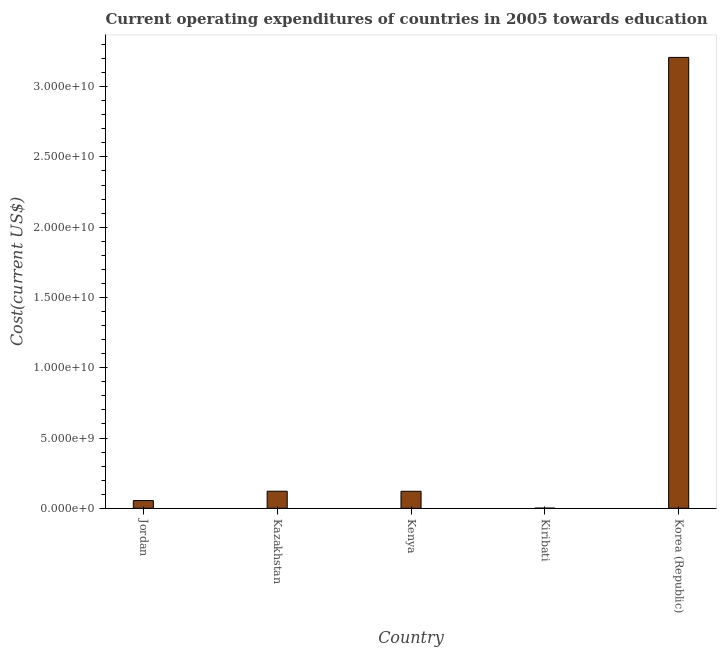Does the graph contain any zero values?
Offer a very short reply. No. What is the title of the graph?
Ensure brevity in your answer.  Current operating expenditures of countries in 2005 towards education. What is the label or title of the Y-axis?
Your answer should be very brief. Cost(current US$). What is the education expenditure in Korea (Republic)?
Give a very brief answer. 3.21e+1. Across all countries, what is the maximum education expenditure?
Keep it short and to the point. 3.21e+1. Across all countries, what is the minimum education expenditure?
Offer a very short reply. 9.83e+06. In which country was the education expenditure maximum?
Ensure brevity in your answer.  Korea (Republic). In which country was the education expenditure minimum?
Offer a very short reply. Kiribati. What is the sum of the education expenditure?
Offer a terse response. 3.51e+1. What is the difference between the education expenditure in Kenya and Kiribati?
Offer a very short reply. 1.20e+09. What is the average education expenditure per country?
Provide a short and direct response. 7.01e+09. What is the median education expenditure?
Your answer should be very brief. 1.21e+09. What is the ratio of the education expenditure in Kenya to that in Kiribati?
Your answer should be very brief. 122.92. Is the difference between the education expenditure in Jordan and Kenya greater than the difference between any two countries?
Make the answer very short. No. What is the difference between the highest and the second highest education expenditure?
Your response must be concise. 3.09e+1. What is the difference between the highest and the lowest education expenditure?
Provide a short and direct response. 3.21e+1. How many bars are there?
Offer a very short reply. 5. Are all the bars in the graph horizontal?
Give a very brief answer. No. How many countries are there in the graph?
Your response must be concise. 5. What is the difference between two consecutive major ticks on the Y-axis?
Provide a short and direct response. 5.00e+09. What is the Cost(current US$) of Jordan?
Your answer should be compact. 5.49e+08. What is the Cost(current US$) in Kazakhstan?
Provide a succinct answer. 1.21e+09. What is the Cost(current US$) of Kenya?
Provide a succinct answer. 1.21e+09. What is the Cost(current US$) in Kiribati?
Keep it short and to the point. 9.83e+06. What is the Cost(current US$) in Korea (Republic)?
Your answer should be compact. 3.21e+1. What is the difference between the Cost(current US$) in Jordan and Kazakhstan?
Make the answer very short. -6.64e+08. What is the difference between the Cost(current US$) in Jordan and Kenya?
Keep it short and to the point. -6.59e+08. What is the difference between the Cost(current US$) in Jordan and Kiribati?
Provide a short and direct response. 5.39e+08. What is the difference between the Cost(current US$) in Jordan and Korea (Republic)?
Your answer should be very brief. -3.15e+1. What is the difference between the Cost(current US$) in Kazakhstan and Kenya?
Give a very brief answer. 4.83e+06. What is the difference between the Cost(current US$) in Kazakhstan and Kiribati?
Give a very brief answer. 1.20e+09. What is the difference between the Cost(current US$) in Kazakhstan and Korea (Republic)?
Offer a very short reply. -3.09e+1. What is the difference between the Cost(current US$) in Kenya and Kiribati?
Ensure brevity in your answer.  1.20e+09. What is the difference between the Cost(current US$) in Kenya and Korea (Republic)?
Make the answer very short. -3.09e+1. What is the difference between the Cost(current US$) in Kiribati and Korea (Republic)?
Provide a short and direct response. -3.21e+1. What is the ratio of the Cost(current US$) in Jordan to that in Kazakhstan?
Make the answer very short. 0.45. What is the ratio of the Cost(current US$) in Jordan to that in Kenya?
Provide a short and direct response. 0.45. What is the ratio of the Cost(current US$) in Jordan to that in Kiribati?
Your response must be concise. 55.84. What is the ratio of the Cost(current US$) in Jordan to that in Korea (Republic)?
Provide a succinct answer. 0.02. What is the ratio of the Cost(current US$) in Kazakhstan to that in Kenya?
Make the answer very short. 1. What is the ratio of the Cost(current US$) in Kazakhstan to that in Kiribati?
Your answer should be very brief. 123.41. What is the ratio of the Cost(current US$) in Kazakhstan to that in Korea (Republic)?
Provide a short and direct response. 0.04. What is the ratio of the Cost(current US$) in Kenya to that in Kiribati?
Keep it short and to the point. 122.92. What is the ratio of the Cost(current US$) in Kenya to that in Korea (Republic)?
Give a very brief answer. 0.04. 